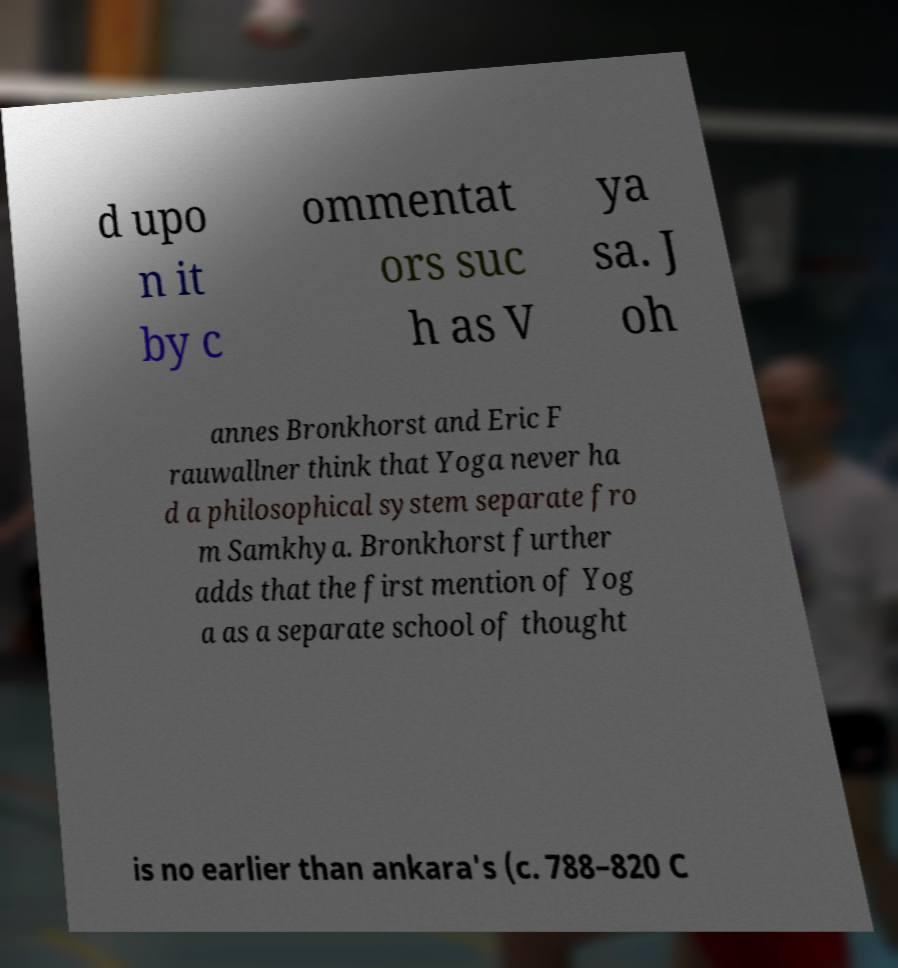Please read and relay the text visible in this image. What does it say? d upo n it by c ommentat ors suc h as V ya sa. J oh annes Bronkhorst and Eric F rauwallner think that Yoga never ha d a philosophical system separate fro m Samkhya. Bronkhorst further adds that the first mention of Yog a as a separate school of thought is no earlier than ankara's (c. 788–820 C 